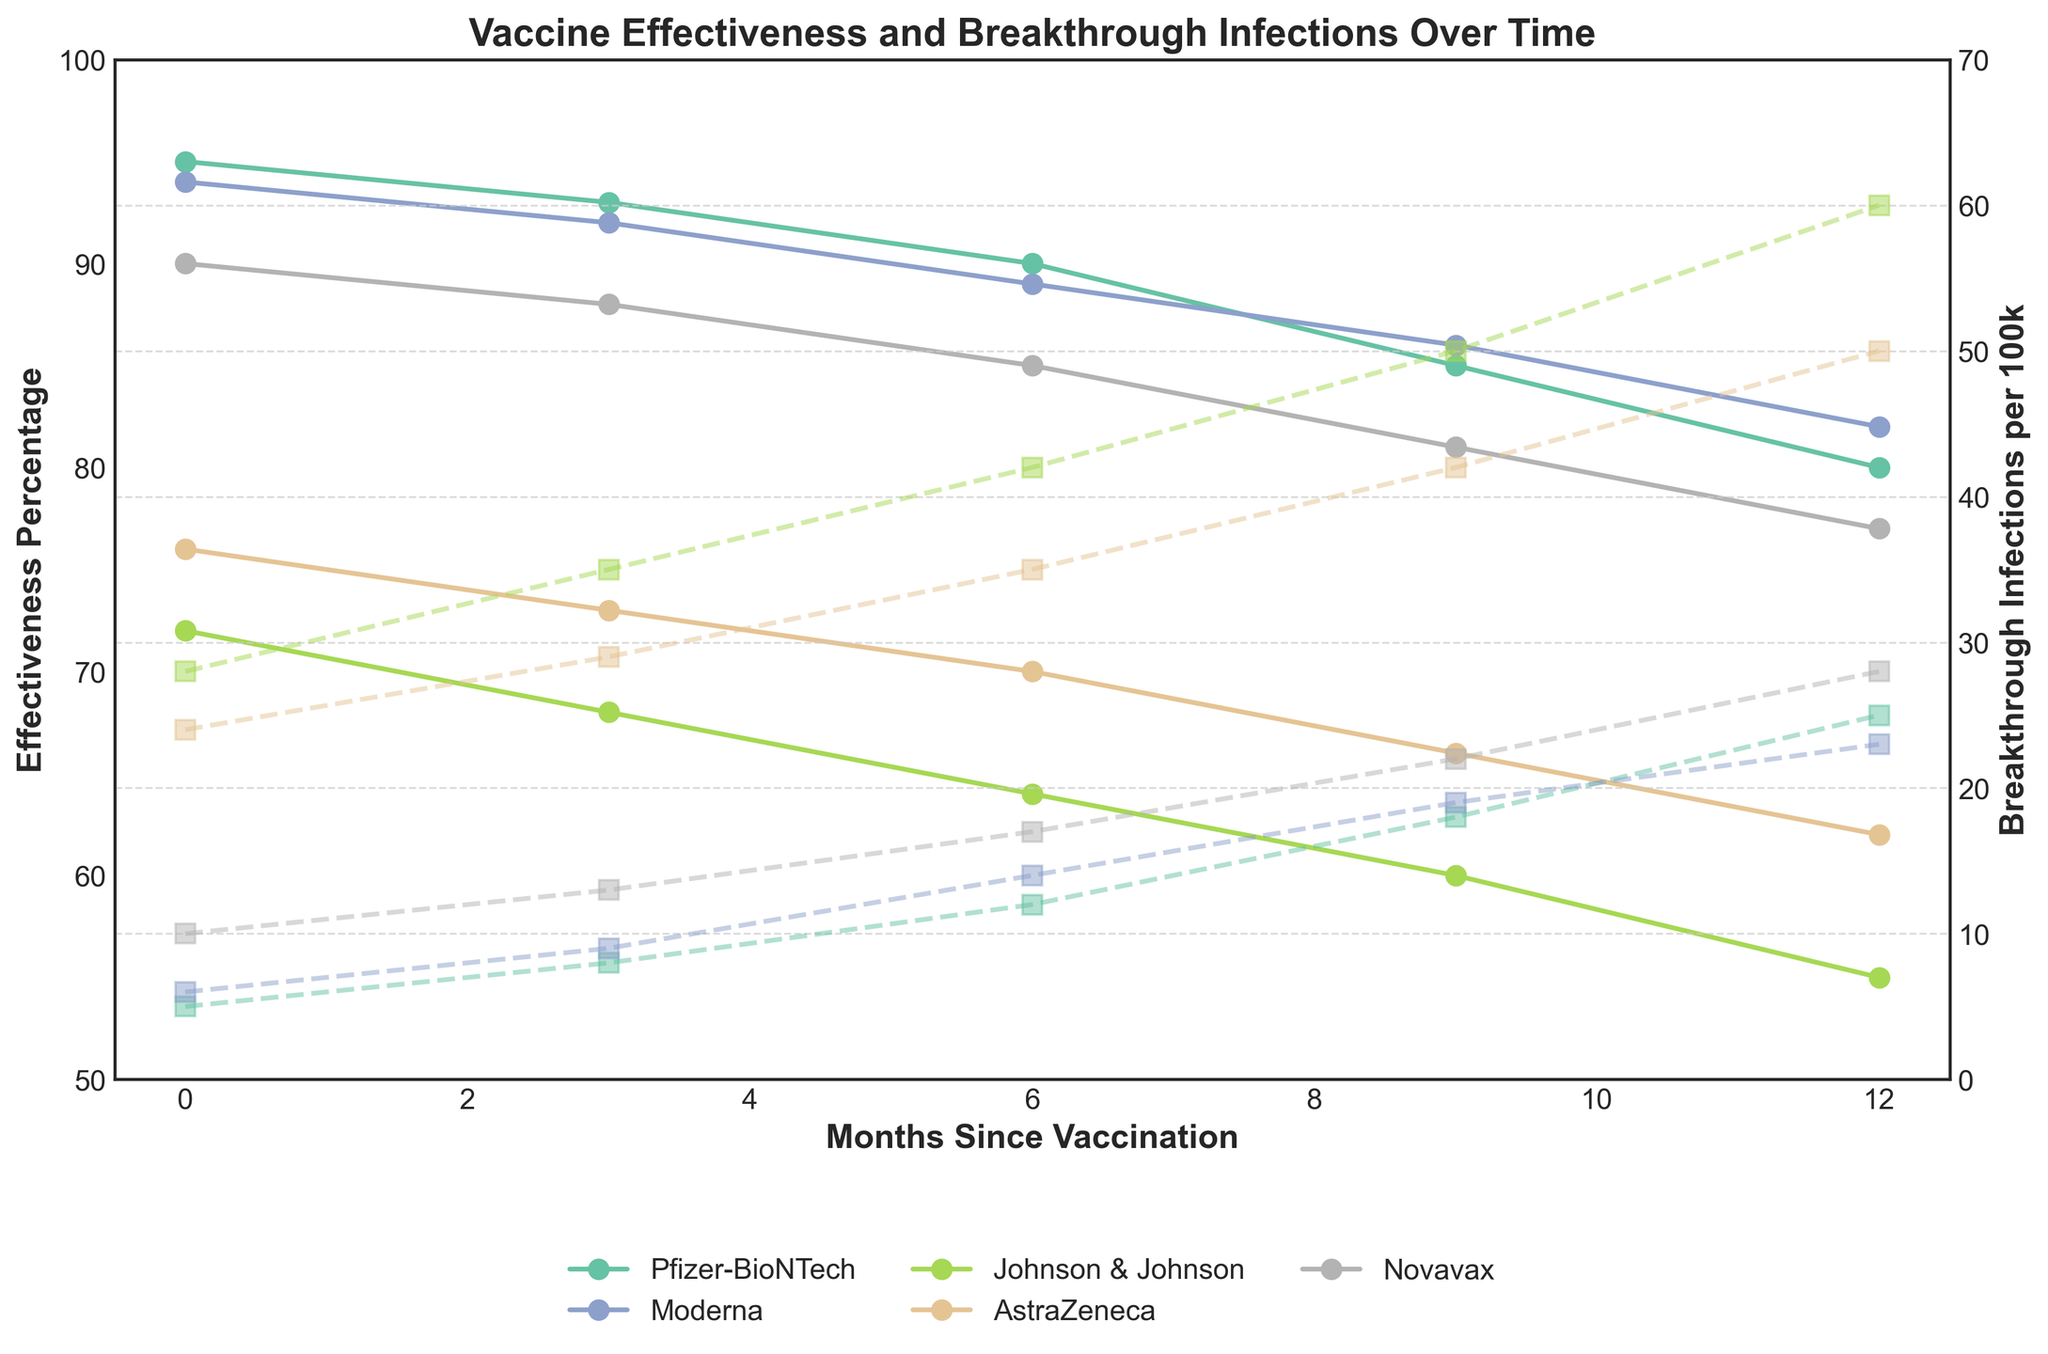What's the trend in vaccine effectiveness for Pfizer-BioNTech over the 12 months? To find the trend, look at the line representing Pfizer-BioNTech and observe how the effectiveness percentage changes from 0 to 12 months. The effectiveness starts at 95%, then progressively decreases to 80% over 12 months.
Answer: Decreasing Which vaccine shows the highest initial effectiveness? To determine this, examine the starting point (0 months) on the effectiveness axis for all vaccines. Pfizer-BioNTech has an initial effectiveness of 95%, which is the highest.
Answer: Pfizer-BioNTech How many breakthrough infections are reported for Moderna at 6 months? Look at the line representing breakthrough infections per 100k for Moderna and identify the value at the 6-month mark. The line intersects at 14.
Answer: 14 By how much does the effectiveness of Johnson & Johnson drop from 0 to 3 months? For Johnson & Johnson, note the effectiveness at 0 months (72%) and at 3 months (68%). Subtract the latter from the former: 72% - 68% = 4%.
Answer: 4% Which vaccine has the least breakthrough infections per 100k at 12 months? For 12 months, check the endpoint of the breakthrough infections lines for all vaccines. Pfizer-BioNTech has the least infections with 25 per 100k.
Answer: Pfizer-BioNTech What is the average effectiveness of AstraZeneca from 0 to 12 months? To calculate the average, sum the effectiveness values (76, 73, 70, 66, 62) and divide by the number of months: (76 + 73 + 70 + 66 + 62) / 5 = 69.4%.
Answer: 69.4% How does the effectiveness of Novavax at 9 months compare to its effectiveness at 12 months? Find the effectiveness values for Novavax at 9 (81%) and 12 months (77%). Since 81% is greater than 77%, effectiveness has decreased.
Answer: Decreased Which vaccine shows the most significant drop in effectiveness over the 12-month period? Calculate the drop for each vaccine by subtracting the effectiveness at 12 months from the initial value (0 months): Pfizer-BioNTech (15%), Moderna (12%), J&J (17%), AstraZeneca (14%), Novavax (13%). Johnson & Johnson shows the largest drop with 17%.
Answer: Johnson & Johnson What is the slope of the line representing Moderna's breakthrough infection rate from 3 to 6 months? To find the slope, use the formula (change in y)/(change in x). For Moderna, the y-values (breakthrough infections) at 3 and 6 months are 9 and 14, respectively, and the change in x (months) is 3: (14-9)/3 = 5/3 ≈ 1.67 per month.
Answer: 1.67 per month Which vaccines maintain over 85% effectiveness after 6 months? Look at the 6-month marks on the effectiveness lines. Pfizer-BioNTech (90%) and Novavax (85%) maintain or surpass 85% effectiveness after 6 months.
Answer: Pfizer-BioNTech and Novavax 